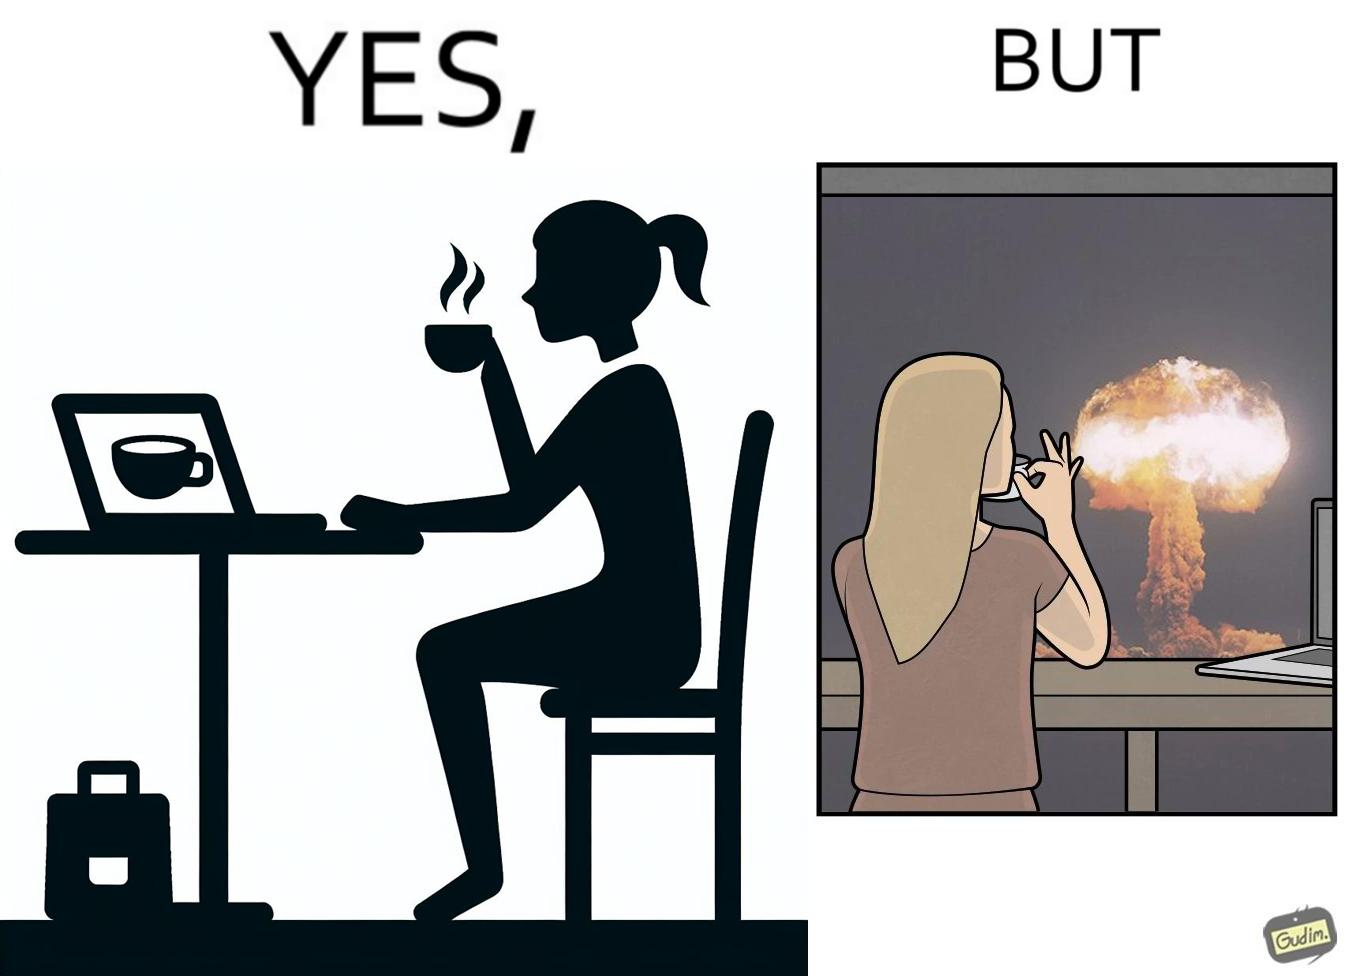Is this image satirical or non-satirical? Yes, this image is satirical. 